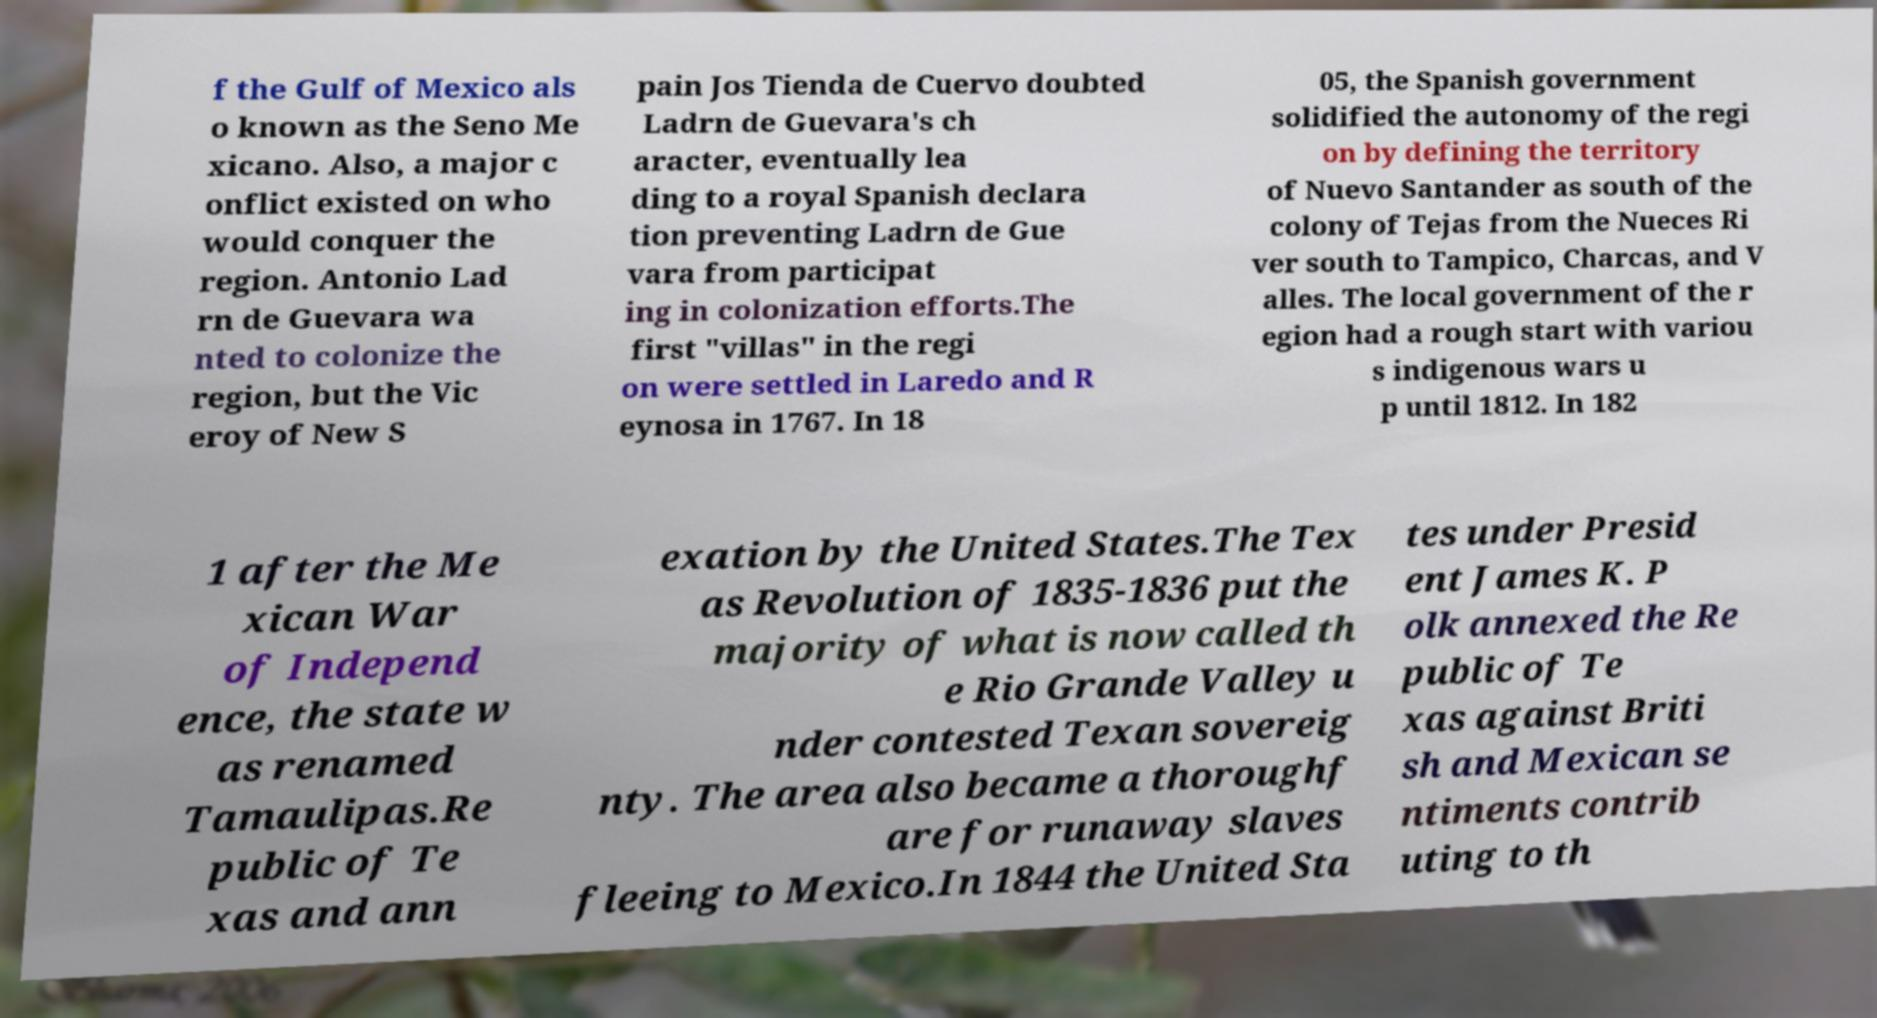Can you accurately transcribe the text from the provided image for me? f the Gulf of Mexico als o known as the Seno Me xicano. Also, a major c onflict existed on who would conquer the region. Antonio Lad rn de Guevara wa nted to colonize the region, but the Vic eroy of New S pain Jos Tienda de Cuervo doubted Ladrn de Guevara's ch aracter, eventually lea ding to a royal Spanish declara tion preventing Ladrn de Gue vara from participat ing in colonization efforts.The first "villas" in the regi on were settled in Laredo and R eynosa in 1767. In 18 05, the Spanish government solidified the autonomy of the regi on by defining the territory of Nuevo Santander as south of the colony of Tejas from the Nueces Ri ver south to Tampico, Charcas, and V alles. The local government of the r egion had a rough start with variou s indigenous wars u p until 1812. In 182 1 after the Me xican War of Independ ence, the state w as renamed Tamaulipas.Re public of Te xas and ann exation by the United States.The Tex as Revolution of 1835-1836 put the majority of what is now called th e Rio Grande Valley u nder contested Texan sovereig nty. The area also became a thoroughf are for runaway slaves fleeing to Mexico.In 1844 the United Sta tes under Presid ent James K. P olk annexed the Re public of Te xas against Briti sh and Mexican se ntiments contrib uting to th 